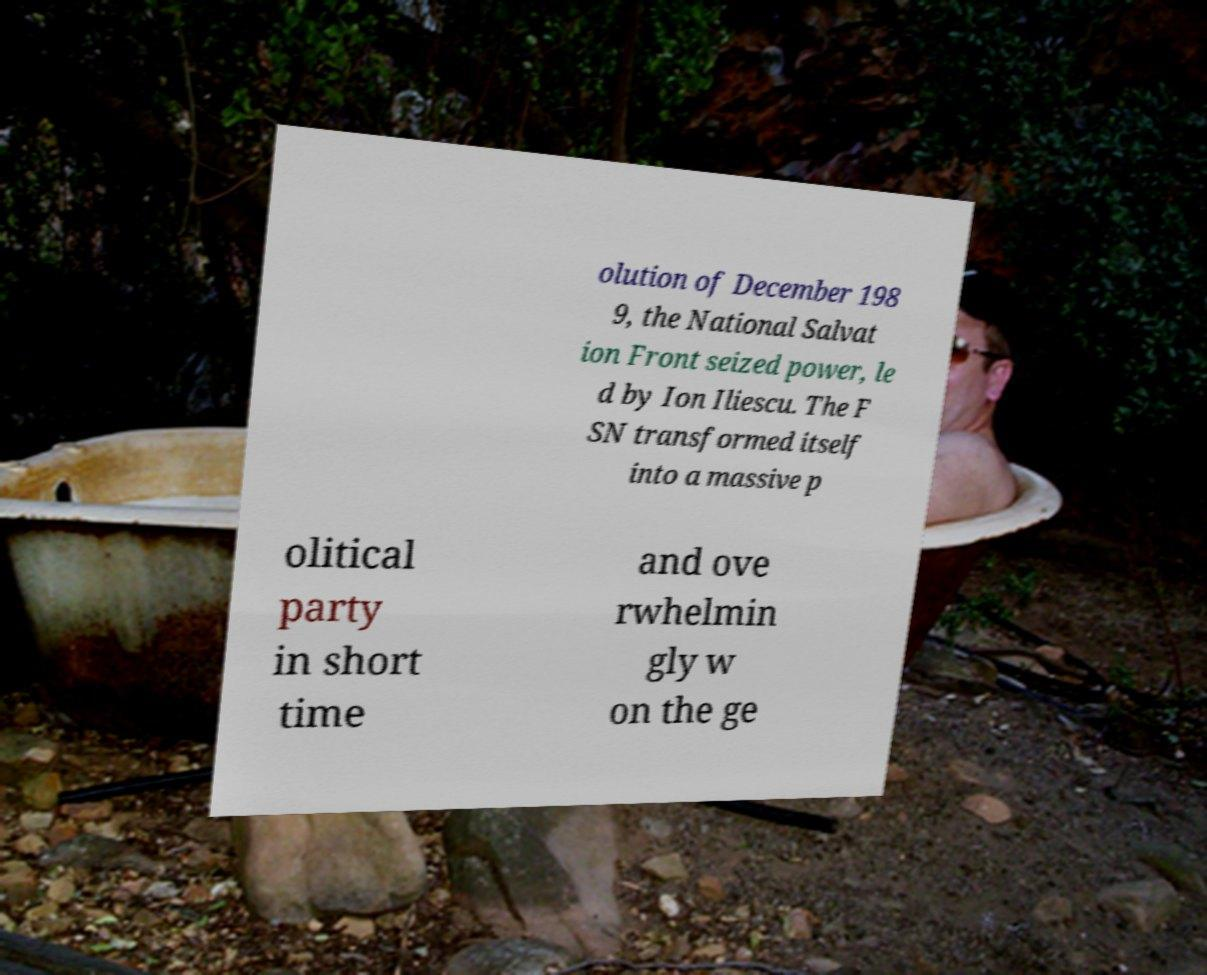Could you assist in decoding the text presented in this image and type it out clearly? olution of December 198 9, the National Salvat ion Front seized power, le d by Ion Iliescu. The F SN transformed itself into a massive p olitical party in short time and ove rwhelmin gly w on the ge 